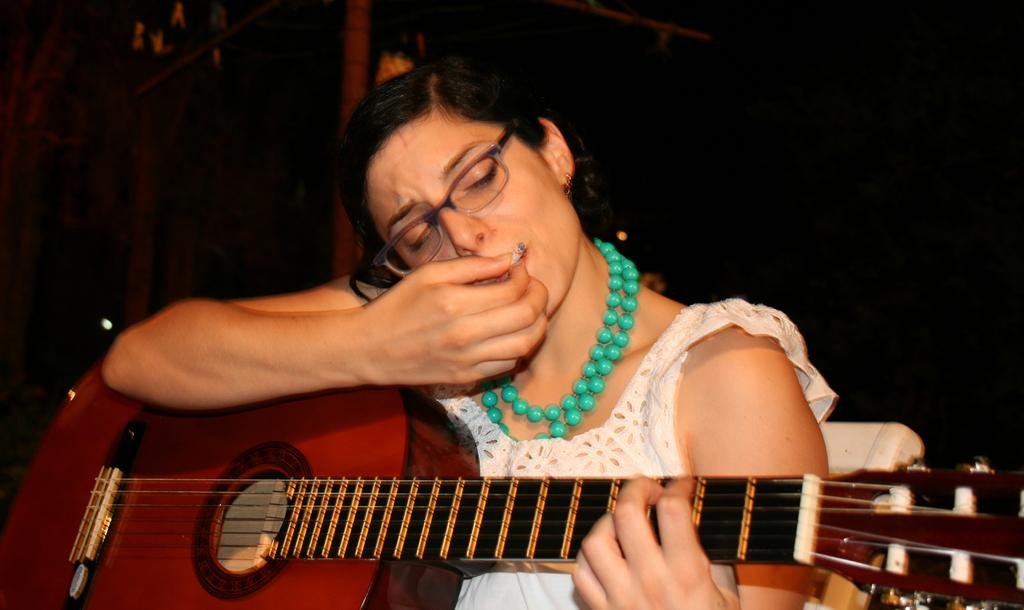Who is the main subject in the image? There is a woman in the image. What is the woman holding in the image? The woman is holding a guitar. What is the woman doing with her mouth in the image? The woman is placing a cigarette in her mouth. What accessory is the woman wearing in the image? The woman is wearing spectacles. What type of mist can be seen surrounding the woman in the image? There is no mist present in the image; it is a clear scene with the woman holding a guitar and placing a cigarette in her mouth. 